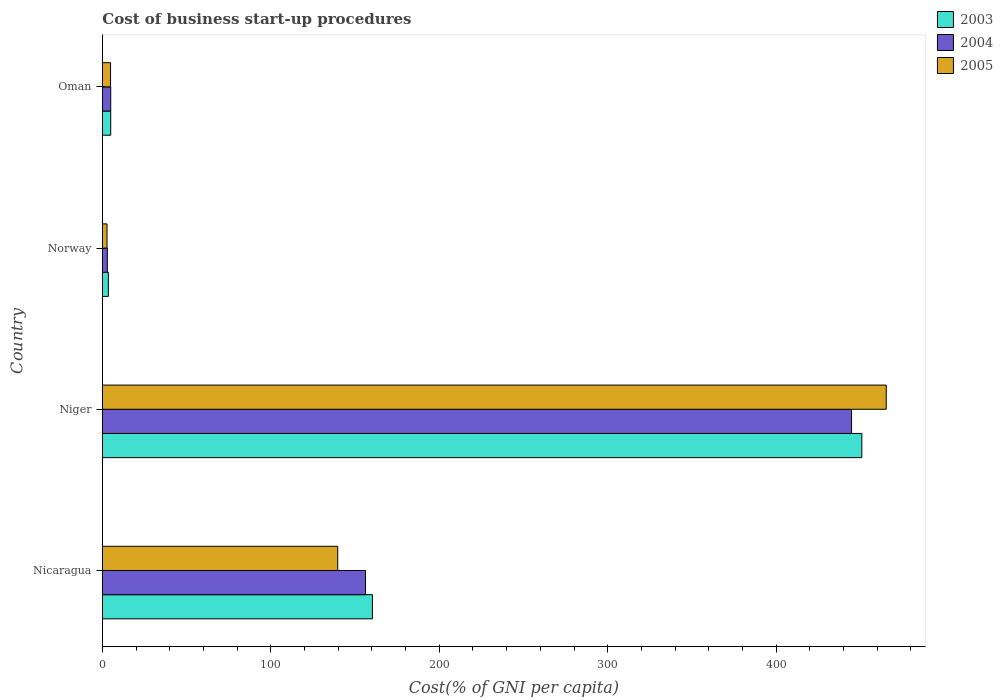Are the number of bars per tick equal to the number of legend labels?
Offer a terse response. Yes. Are the number of bars on each tick of the Y-axis equal?
Your response must be concise. Yes. How many bars are there on the 2nd tick from the bottom?
Offer a very short reply. 3. What is the label of the 3rd group of bars from the top?
Offer a very short reply. Niger. Across all countries, what is the maximum cost of business start-up procedures in 2003?
Your answer should be very brief. 450.9. Across all countries, what is the minimum cost of business start-up procedures in 2005?
Offer a terse response. 2.7. In which country was the cost of business start-up procedures in 2004 maximum?
Provide a succinct answer. Niger. What is the total cost of business start-up procedures in 2004 in the graph?
Your response must be concise. 608.8. What is the difference between the cost of business start-up procedures in 2004 in Niger and that in Norway?
Provide a short and direct response. 441.9. What is the difference between the cost of business start-up procedures in 2003 in Nicaragua and the cost of business start-up procedures in 2005 in Norway?
Give a very brief answer. 157.6. What is the average cost of business start-up procedures in 2005 per country?
Your response must be concise. 153.15. What is the difference between the cost of business start-up procedures in 2005 and cost of business start-up procedures in 2004 in Oman?
Provide a succinct answer. -0.1. What is the ratio of the cost of business start-up procedures in 2005 in Nicaragua to that in Norway?
Your answer should be very brief. 51.74. Is the difference between the cost of business start-up procedures in 2005 in Nicaragua and Niger greater than the difference between the cost of business start-up procedures in 2004 in Nicaragua and Niger?
Ensure brevity in your answer.  No. What is the difference between the highest and the second highest cost of business start-up procedures in 2004?
Your answer should be compact. 288.6. What is the difference between the highest and the lowest cost of business start-up procedures in 2005?
Give a very brief answer. 462.7. Is the sum of the cost of business start-up procedures in 2003 in Nicaragua and Norway greater than the maximum cost of business start-up procedures in 2005 across all countries?
Your answer should be very brief. No. What does the 3rd bar from the bottom in Niger represents?
Your answer should be compact. 2005. Are all the bars in the graph horizontal?
Your response must be concise. Yes. Are the values on the major ticks of X-axis written in scientific E-notation?
Keep it short and to the point. No. Where does the legend appear in the graph?
Your answer should be very brief. Top right. How are the legend labels stacked?
Provide a short and direct response. Vertical. What is the title of the graph?
Give a very brief answer. Cost of business start-up procedures. Does "1980" appear as one of the legend labels in the graph?
Your response must be concise. No. What is the label or title of the X-axis?
Make the answer very short. Cost(% of GNI per capita). What is the label or title of the Y-axis?
Your answer should be very brief. Country. What is the Cost(% of GNI per capita) of 2003 in Nicaragua?
Keep it short and to the point. 160.3. What is the Cost(% of GNI per capita) in 2004 in Nicaragua?
Provide a succinct answer. 156.2. What is the Cost(% of GNI per capita) of 2005 in Nicaragua?
Offer a terse response. 139.7. What is the Cost(% of GNI per capita) of 2003 in Niger?
Give a very brief answer. 450.9. What is the Cost(% of GNI per capita) of 2004 in Niger?
Your response must be concise. 444.8. What is the Cost(% of GNI per capita) of 2005 in Niger?
Provide a short and direct response. 465.4. What is the Cost(% of GNI per capita) in 2003 in Norway?
Ensure brevity in your answer.  3.5. What is the Cost(% of GNI per capita) in 2005 in Norway?
Your response must be concise. 2.7. What is the Cost(% of GNI per capita) of 2003 in Oman?
Your response must be concise. 4.9. What is the Cost(% of GNI per capita) of 2004 in Oman?
Keep it short and to the point. 4.9. What is the Cost(% of GNI per capita) in 2005 in Oman?
Provide a succinct answer. 4.8. Across all countries, what is the maximum Cost(% of GNI per capita) in 2003?
Give a very brief answer. 450.9. Across all countries, what is the maximum Cost(% of GNI per capita) of 2004?
Provide a succinct answer. 444.8. Across all countries, what is the maximum Cost(% of GNI per capita) of 2005?
Your answer should be very brief. 465.4. Across all countries, what is the minimum Cost(% of GNI per capita) of 2003?
Keep it short and to the point. 3.5. What is the total Cost(% of GNI per capita) in 2003 in the graph?
Ensure brevity in your answer.  619.6. What is the total Cost(% of GNI per capita) of 2004 in the graph?
Offer a very short reply. 608.8. What is the total Cost(% of GNI per capita) of 2005 in the graph?
Your answer should be compact. 612.6. What is the difference between the Cost(% of GNI per capita) of 2003 in Nicaragua and that in Niger?
Provide a short and direct response. -290.6. What is the difference between the Cost(% of GNI per capita) in 2004 in Nicaragua and that in Niger?
Make the answer very short. -288.6. What is the difference between the Cost(% of GNI per capita) of 2005 in Nicaragua and that in Niger?
Ensure brevity in your answer.  -325.7. What is the difference between the Cost(% of GNI per capita) of 2003 in Nicaragua and that in Norway?
Give a very brief answer. 156.8. What is the difference between the Cost(% of GNI per capita) of 2004 in Nicaragua and that in Norway?
Your answer should be compact. 153.3. What is the difference between the Cost(% of GNI per capita) of 2005 in Nicaragua and that in Norway?
Your response must be concise. 137. What is the difference between the Cost(% of GNI per capita) in 2003 in Nicaragua and that in Oman?
Keep it short and to the point. 155.4. What is the difference between the Cost(% of GNI per capita) in 2004 in Nicaragua and that in Oman?
Give a very brief answer. 151.3. What is the difference between the Cost(% of GNI per capita) in 2005 in Nicaragua and that in Oman?
Keep it short and to the point. 134.9. What is the difference between the Cost(% of GNI per capita) of 2003 in Niger and that in Norway?
Make the answer very short. 447.4. What is the difference between the Cost(% of GNI per capita) of 2004 in Niger and that in Norway?
Ensure brevity in your answer.  441.9. What is the difference between the Cost(% of GNI per capita) in 2005 in Niger and that in Norway?
Provide a succinct answer. 462.7. What is the difference between the Cost(% of GNI per capita) in 2003 in Niger and that in Oman?
Your answer should be very brief. 446. What is the difference between the Cost(% of GNI per capita) of 2004 in Niger and that in Oman?
Make the answer very short. 439.9. What is the difference between the Cost(% of GNI per capita) of 2005 in Niger and that in Oman?
Provide a short and direct response. 460.6. What is the difference between the Cost(% of GNI per capita) of 2003 in Norway and that in Oman?
Keep it short and to the point. -1.4. What is the difference between the Cost(% of GNI per capita) in 2004 in Norway and that in Oman?
Ensure brevity in your answer.  -2. What is the difference between the Cost(% of GNI per capita) of 2003 in Nicaragua and the Cost(% of GNI per capita) of 2004 in Niger?
Provide a short and direct response. -284.5. What is the difference between the Cost(% of GNI per capita) in 2003 in Nicaragua and the Cost(% of GNI per capita) in 2005 in Niger?
Give a very brief answer. -305.1. What is the difference between the Cost(% of GNI per capita) of 2004 in Nicaragua and the Cost(% of GNI per capita) of 2005 in Niger?
Provide a short and direct response. -309.2. What is the difference between the Cost(% of GNI per capita) of 2003 in Nicaragua and the Cost(% of GNI per capita) of 2004 in Norway?
Keep it short and to the point. 157.4. What is the difference between the Cost(% of GNI per capita) of 2003 in Nicaragua and the Cost(% of GNI per capita) of 2005 in Norway?
Ensure brevity in your answer.  157.6. What is the difference between the Cost(% of GNI per capita) in 2004 in Nicaragua and the Cost(% of GNI per capita) in 2005 in Norway?
Provide a succinct answer. 153.5. What is the difference between the Cost(% of GNI per capita) in 2003 in Nicaragua and the Cost(% of GNI per capita) in 2004 in Oman?
Your answer should be compact. 155.4. What is the difference between the Cost(% of GNI per capita) in 2003 in Nicaragua and the Cost(% of GNI per capita) in 2005 in Oman?
Your answer should be very brief. 155.5. What is the difference between the Cost(% of GNI per capita) in 2004 in Nicaragua and the Cost(% of GNI per capita) in 2005 in Oman?
Make the answer very short. 151.4. What is the difference between the Cost(% of GNI per capita) in 2003 in Niger and the Cost(% of GNI per capita) in 2004 in Norway?
Make the answer very short. 448. What is the difference between the Cost(% of GNI per capita) in 2003 in Niger and the Cost(% of GNI per capita) in 2005 in Norway?
Make the answer very short. 448.2. What is the difference between the Cost(% of GNI per capita) in 2004 in Niger and the Cost(% of GNI per capita) in 2005 in Norway?
Your answer should be very brief. 442.1. What is the difference between the Cost(% of GNI per capita) of 2003 in Niger and the Cost(% of GNI per capita) of 2004 in Oman?
Make the answer very short. 446. What is the difference between the Cost(% of GNI per capita) in 2003 in Niger and the Cost(% of GNI per capita) in 2005 in Oman?
Give a very brief answer. 446.1. What is the difference between the Cost(% of GNI per capita) of 2004 in Niger and the Cost(% of GNI per capita) of 2005 in Oman?
Give a very brief answer. 440. What is the difference between the Cost(% of GNI per capita) in 2003 in Norway and the Cost(% of GNI per capita) in 2004 in Oman?
Provide a short and direct response. -1.4. What is the average Cost(% of GNI per capita) of 2003 per country?
Your answer should be compact. 154.9. What is the average Cost(% of GNI per capita) in 2004 per country?
Your answer should be very brief. 152.2. What is the average Cost(% of GNI per capita) in 2005 per country?
Offer a terse response. 153.15. What is the difference between the Cost(% of GNI per capita) in 2003 and Cost(% of GNI per capita) in 2005 in Nicaragua?
Offer a terse response. 20.6. What is the difference between the Cost(% of GNI per capita) in 2003 and Cost(% of GNI per capita) in 2004 in Niger?
Your response must be concise. 6.1. What is the difference between the Cost(% of GNI per capita) of 2004 and Cost(% of GNI per capita) of 2005 in Niger?
Provide a succinct answer. -20.6. What is the difference between the Cost(% of GNI per capita) of 2004 and Cost(% of GNI per capita) of 2005 in Norway?
Your answer should be very brief. 0.2. What is the difference between the Cost(% of GNI per capita) in 2003 and Cost(% of GNI per capita) in 2004 in Oman?
Give a very brief answer. 0. What is the difference between the Cost(% of GNI per capita) of 2004 and Cost(% of GNI per capita) of 2005 in Oman?
Ensure brevity in your answer.  0.1. What is the ratio of the Cost(% of GNI per capita) of 2003 in Nicaragua to that in Niger?
Offer a very short reply. 0.36. What is the ratio of the Cost(% of GNI per capita) of 2004 in Nicaragua to that in Niger?
Make the answer very short. 0.35. What is the ratio of the Cost(% of GNI per capita) in 2005 in Nicaragua to that in Niger?
Give a very brief answer. 0.3. What is the ratio of the Cost(% of GNI per capita) in 2003 in Nicaragua to that in Norway?
Offer a terse response. 45.8. What is the ratio of the Cost(% of GNI per capita) of 2004 in Nicaragua to that in Norway?
Keep it short and to the point. 53.86. What is the ratio of the Cost(% of GNI per capita) of 2005 in Nicaragua to that in Norway?
Your answer should be compact. 51.74. What is the ratio of the Cost(% of GNI per capita) in 2003 in Nicaragua to that in Oman?
Provide a succinct answer. 32.71. What is the ratio of the Cost(% of GNI per capita) of 2004 in Nicaragua to that in Oman?
Ensure brevity in your answer.  31.88. What is the ratio of the Cost(% of GNI per capita) of 2005 in Nicaragua to that in Oman?
Offer a very short reply. 29.1. What is the ratio of the Cost(% of GNI per capita) of 2003 in Niger to that in Norway?
Your answer should be very brief. 128.83. What is the ratio of the Cost(% of GNI per capita) in 2004 in Niger to that in Norway?
Your response must be concise. 153.38. What is the ratio of the Cost(% of GNI per capita) of 2005 in Niger to that in Norway?
Your response must be concise. 172.37. What is the ratio of the Cost(% of GNI per capita) in 2003 in Niger to that in Oman?
Your answer should be compact. 92.02. What is the ratio of the Cost(% of GNI per capita) in 2004 in Niger to that in Oman?
Keep it short and to the point. 90.78. What is the ratio of the Cost(% of GNI per capita) of 2005 in Niger to that in Oman?
Make the answer very short. 96.96. What is the ratio of the Cost(% of GNI per capita) in 2004 in Norway to that in Oman?
Offer a terse response. 0.59. What is the ratio of the Cost(% of GNI per capita) of 2005 in Norway to that in Oman?
Provide a succinct answer. 0.56. What is the difference between the highest and the second highest Cost(% of GNI per capita) in 2003?
Provide a succinct answer. 290.6. What is the difference between the highest and the second highest Cost(% of GNI per capita) of 2004?
Your answer should be compact. 288.6. What is the difference between the highest and the second highest Cost(% of GNI per capita) of 2005?
Your response must be concise. 325.7. What is the difference between the highest and the lowest Cost(% of GNI per capita) in 2003?
Offer a terse response. 447.4. What is the difference between the highest and the lowest Cost(% of GNI per capita) of 2004?
Your response must be concise. 441.9. What is the difference between the highest and the lowest Cost(% of GNI per capita) in 2005?
Offer a very short reply. 462.7. 